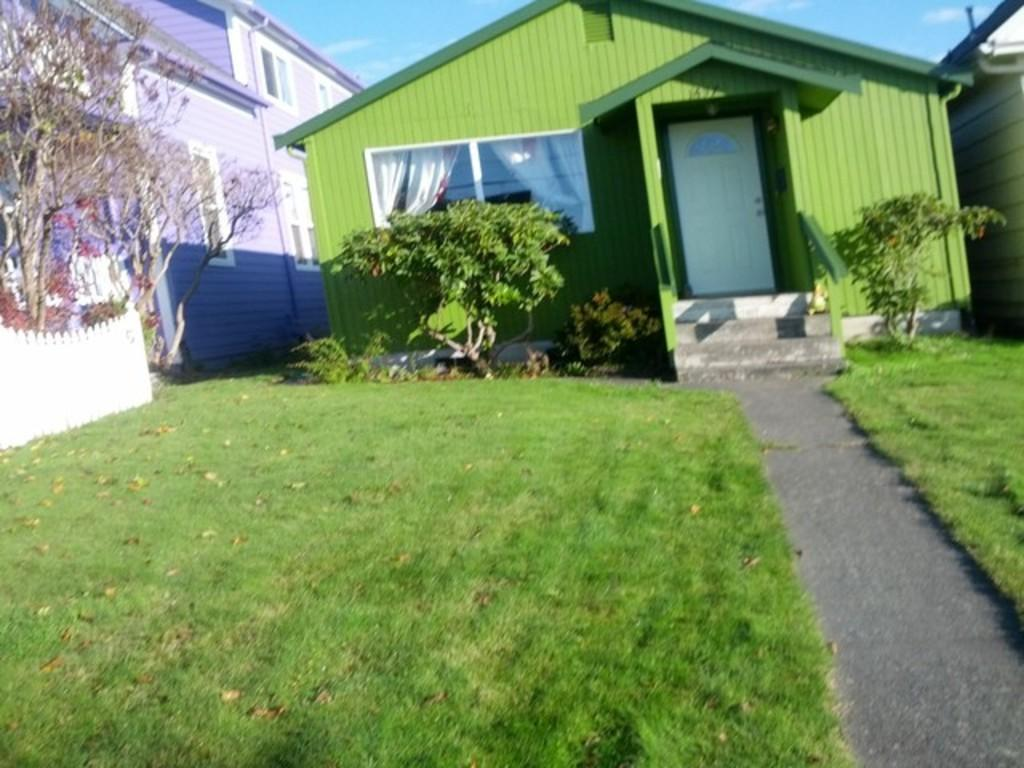What type of structures can be seen in the image? There are houses in the image. What type of vegetation is visible in the image? There is grass visible in the image. What other natural elements can be seen in the image? There are trees in the image. What type of hole can be seen in the image? There is no hole present in the image. What angle is the image taken from? The angle from which the image is taken is not mentioned in the provided facts. 